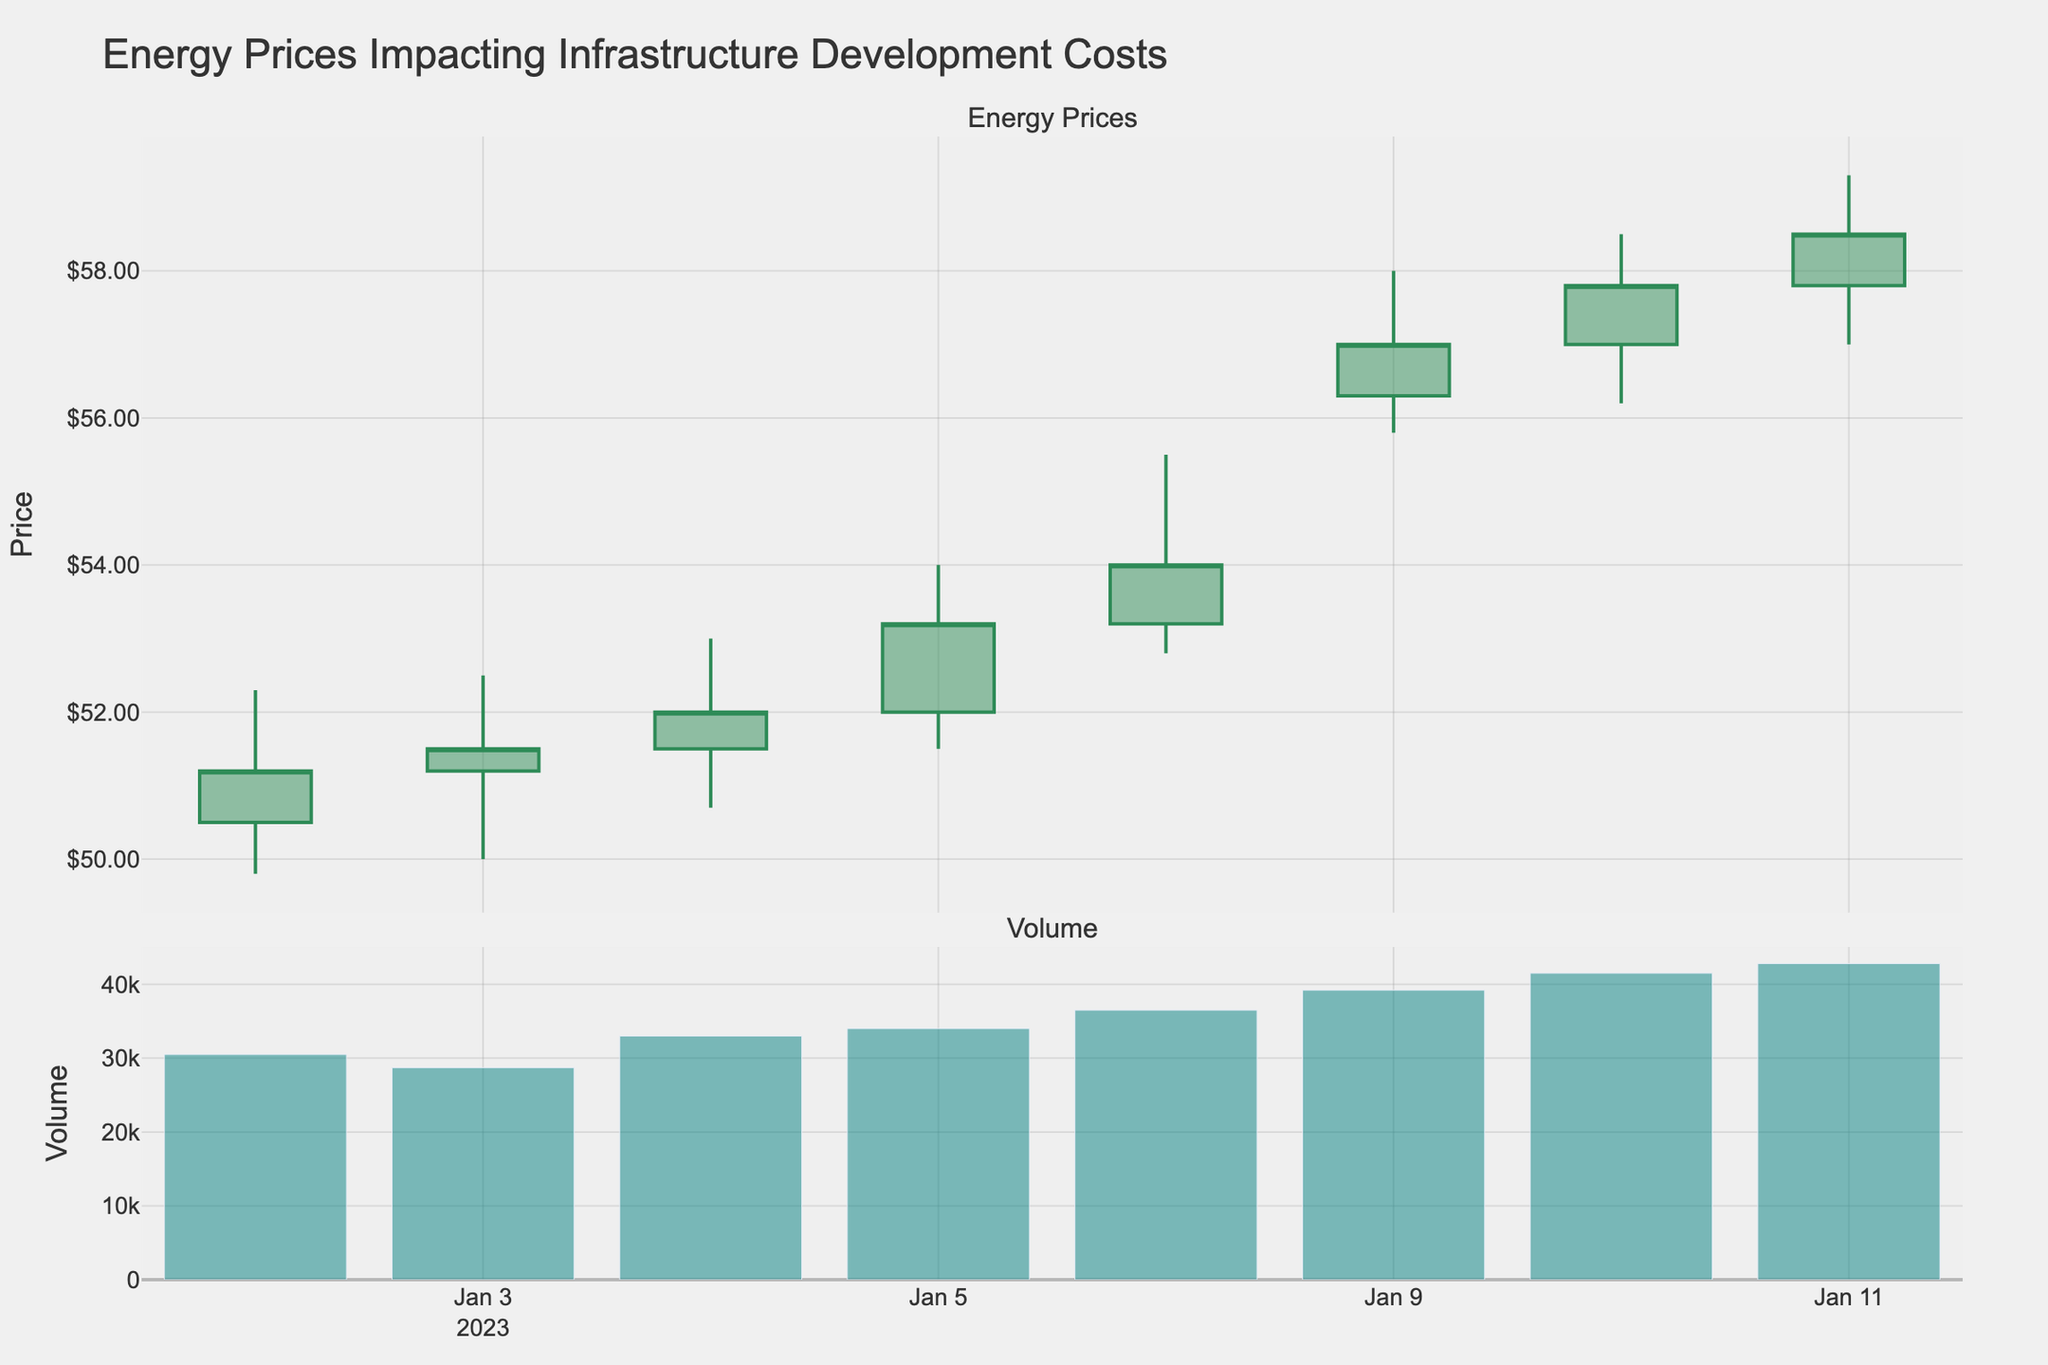What is the title of the figure? The title is displayed prominently at the top of the figure.
Answer: Energy Prices Impacting Infrastructure Development Costs How many candlestick data points are there in the figure? Count the number of individual candlesticks, which represent the days.
Answer: 10 On which date did the stock have the highest closing price? Examine the closing prices at the top of each candlestick and find the highest.
Answer: 2023-01-11 What color represents a price increase in the candlestick plot? The color representing a price increase is used for candlesticks where the closing price is higher than the opening price.
Answer: Green What was the highest volume traded and on which date did it occur? Look at the bar chart in the second subplot and identify the tallest bar and its corresponding date.
Answer: 42800 on 2023-01-11 Which day had the largest difference between the high and low prices? Calculate the difference (high - low) for each day and identify the day with the largest difference.
Answer: 2023-01-06 Compare the opening and closing prices on 2023-01-03. Did the price increase or decrease? Look at the opening and closing prices for 2023-01-03. The price increases if the closing price is higher than the opening price and decreases if the closing price is lower.
Answer: Increase What is the average closing price over the given period? Add together all the closing prices and divide by the number of days. Calculation: (51.2 + 51.5 + 52.0 + 53.2 + 54.0 + 55.0 + 56.3 + 57.0 + 57.8 + 58.5) / 10
Answer: 54.65 Did the volume traded generally increase, decrease, or stay the same over the period? Observe the trend in the volume bar chart from the first date to the last date.
Answer: Increase 